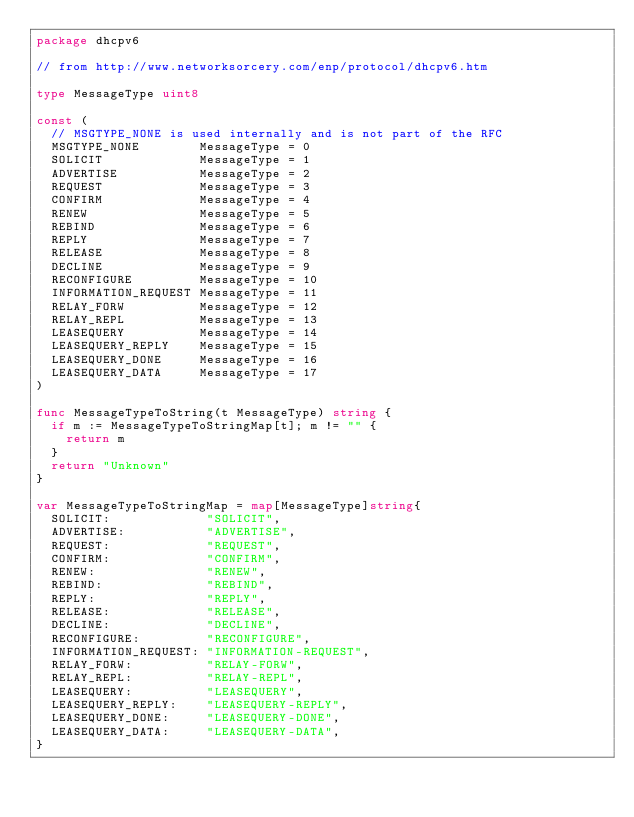Convert code to text. <code><loc_0><loc_0><loc_500><loc_500><_Go_>package dhcpv6

// from http://www.networksorcery.com/enp/protocol/dhcpv6.htm

type MessageType uint8

const (
	// MSGTYPE_NONE is used internally and is not part of the RFC
	MSGTYPE_NONE        MessageType = 0
	SOLICIT             MessageType = 1
	ADVERTISE           MessageType = 2
	REQUEST             MessageType = 3
	CONFIRM             MessageType = 4
	RENEW               MessageType = 5
	REBIND              MessageType = 6
	REPLY               MessageType = 7
	RELEASE             MessageType = 8
	DECLINE             MessageType = 9
	RECONFIGURE         MessageType = 10
	INFORMATION_REQUEST MessageType = 11
	RELAY_FORW          MessageType = 12
	RELAY_REPL          MessageType = 13
	LEASEQUERY          MessageType = 14
	LEASEQUERY_REPLY    MessageType = 15
	LEASEQUERY_DONE     MessageType = 16
	LEASEQUERY_DATA     MessageType = 17
)

func MessageTypeToString(t MessageType) string {
	if m := MessageTypeToStringMap[t]; m != "" {
		return m
	}
	return "Unknown"
}

var MessageTypeToStringMap = map[MessageType]string{
	SOLICIT:             "SOLICIT",
	ADVERTISE:           "ADVERTISE",
	REQUEST:             "REQUEST",
	CONFIRM:             "CONFIRM",
	RENEW:               "RENEW",
	REBIND:              "REBIND",
	REPLY:               "REPLY",
	RELEASE:             "RELEASE",
	DECLINE:             "DECLINE",
	RECONFIGURE:         "RECONFIGURE",
	INFORMATION_REQUEST: "INFORMATION-REQUEST",
	RELAY_FORW:          "RELAY-FORW",
	RELAY_REPL:          "RELAY-REPL",
	LEASEQUERY:          "LEASEQUERY",
	LEASEQUERY_REPLY:    "LEASEQUERY-REPLY",
	LEASEQUERY_DONE:     "LEASEQUERY-DONE",
	LEASEQUERY_DATA:     "LEASEQUERY-DATA",
}
</code> 